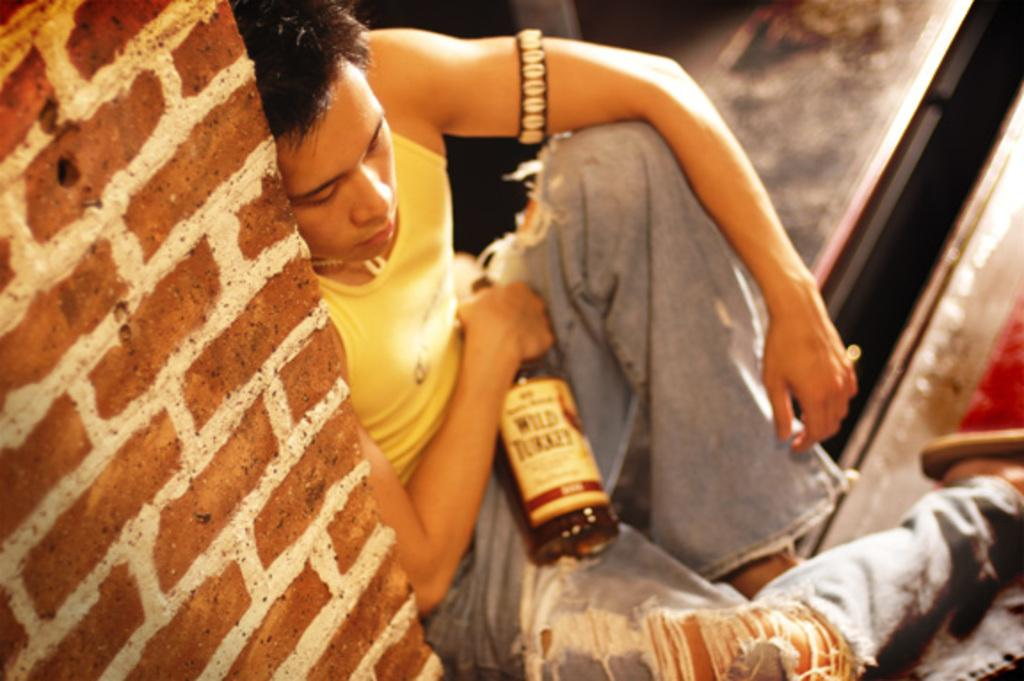Who is present in the image? There is a man in the image. What is the man doing in the image? The man is seated on the ground and holding a bottle with his hand. What is the background of the image? There is a brick wall in the image. What else can be seen on the man's hand? The man has a band on his other hand. What type of territory is the man trying to claim with the banana in the image? There is no banana present in the image, and the man is not trying to claim any territory. 